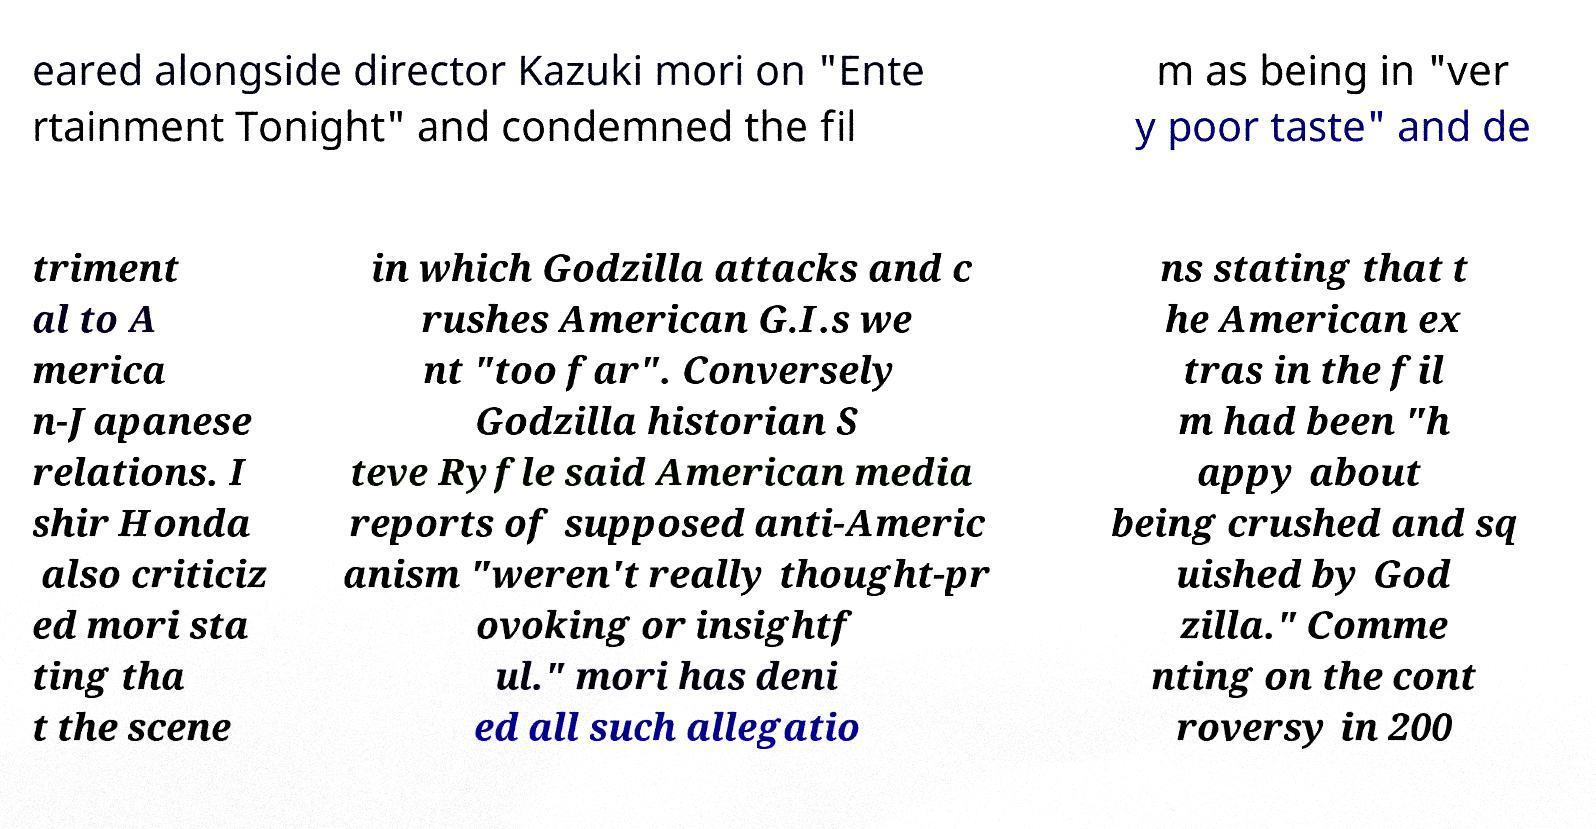Please identify and transcribe the text found in this image. eared alongside director Kazuki mori on "Ente rtainment Tonight" and condemned the fil m as being in "ver y poor taste" and de triment al to A merica n-Japanese relations. I shir Honda also criticiz ed mori sta ting tha t the scene in which Godzilla attacks and c rushes American G.I.s we nt "too far". Conversely Godzilla historian S teve Ryfle said American media reports of supposed anti-Americ anism "weren't really thought-pr ovoking or insightf ul." mori has deni ed all such allegatio ns stating that t he American ex tras in the fil m had been "h appy about being crushed and sq uished by God zilla." Comme nting on the cont roversy in 200 